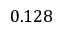Convert formula to latex. <formula><loc_0><loc_0><loc_500><loc_500>0 . 1 2 8</formula> 